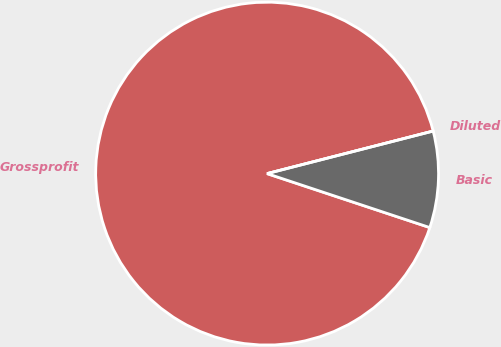Convert chart. <chart><loc_0><loc_0><loc_500><loc_500><pie_chart><fcel>Grossprofit<fcel>Basic<fcel>Diluted<nl><fcel>90.91%<fcel>9.09%<fcel>0.0%<nl></chart> 